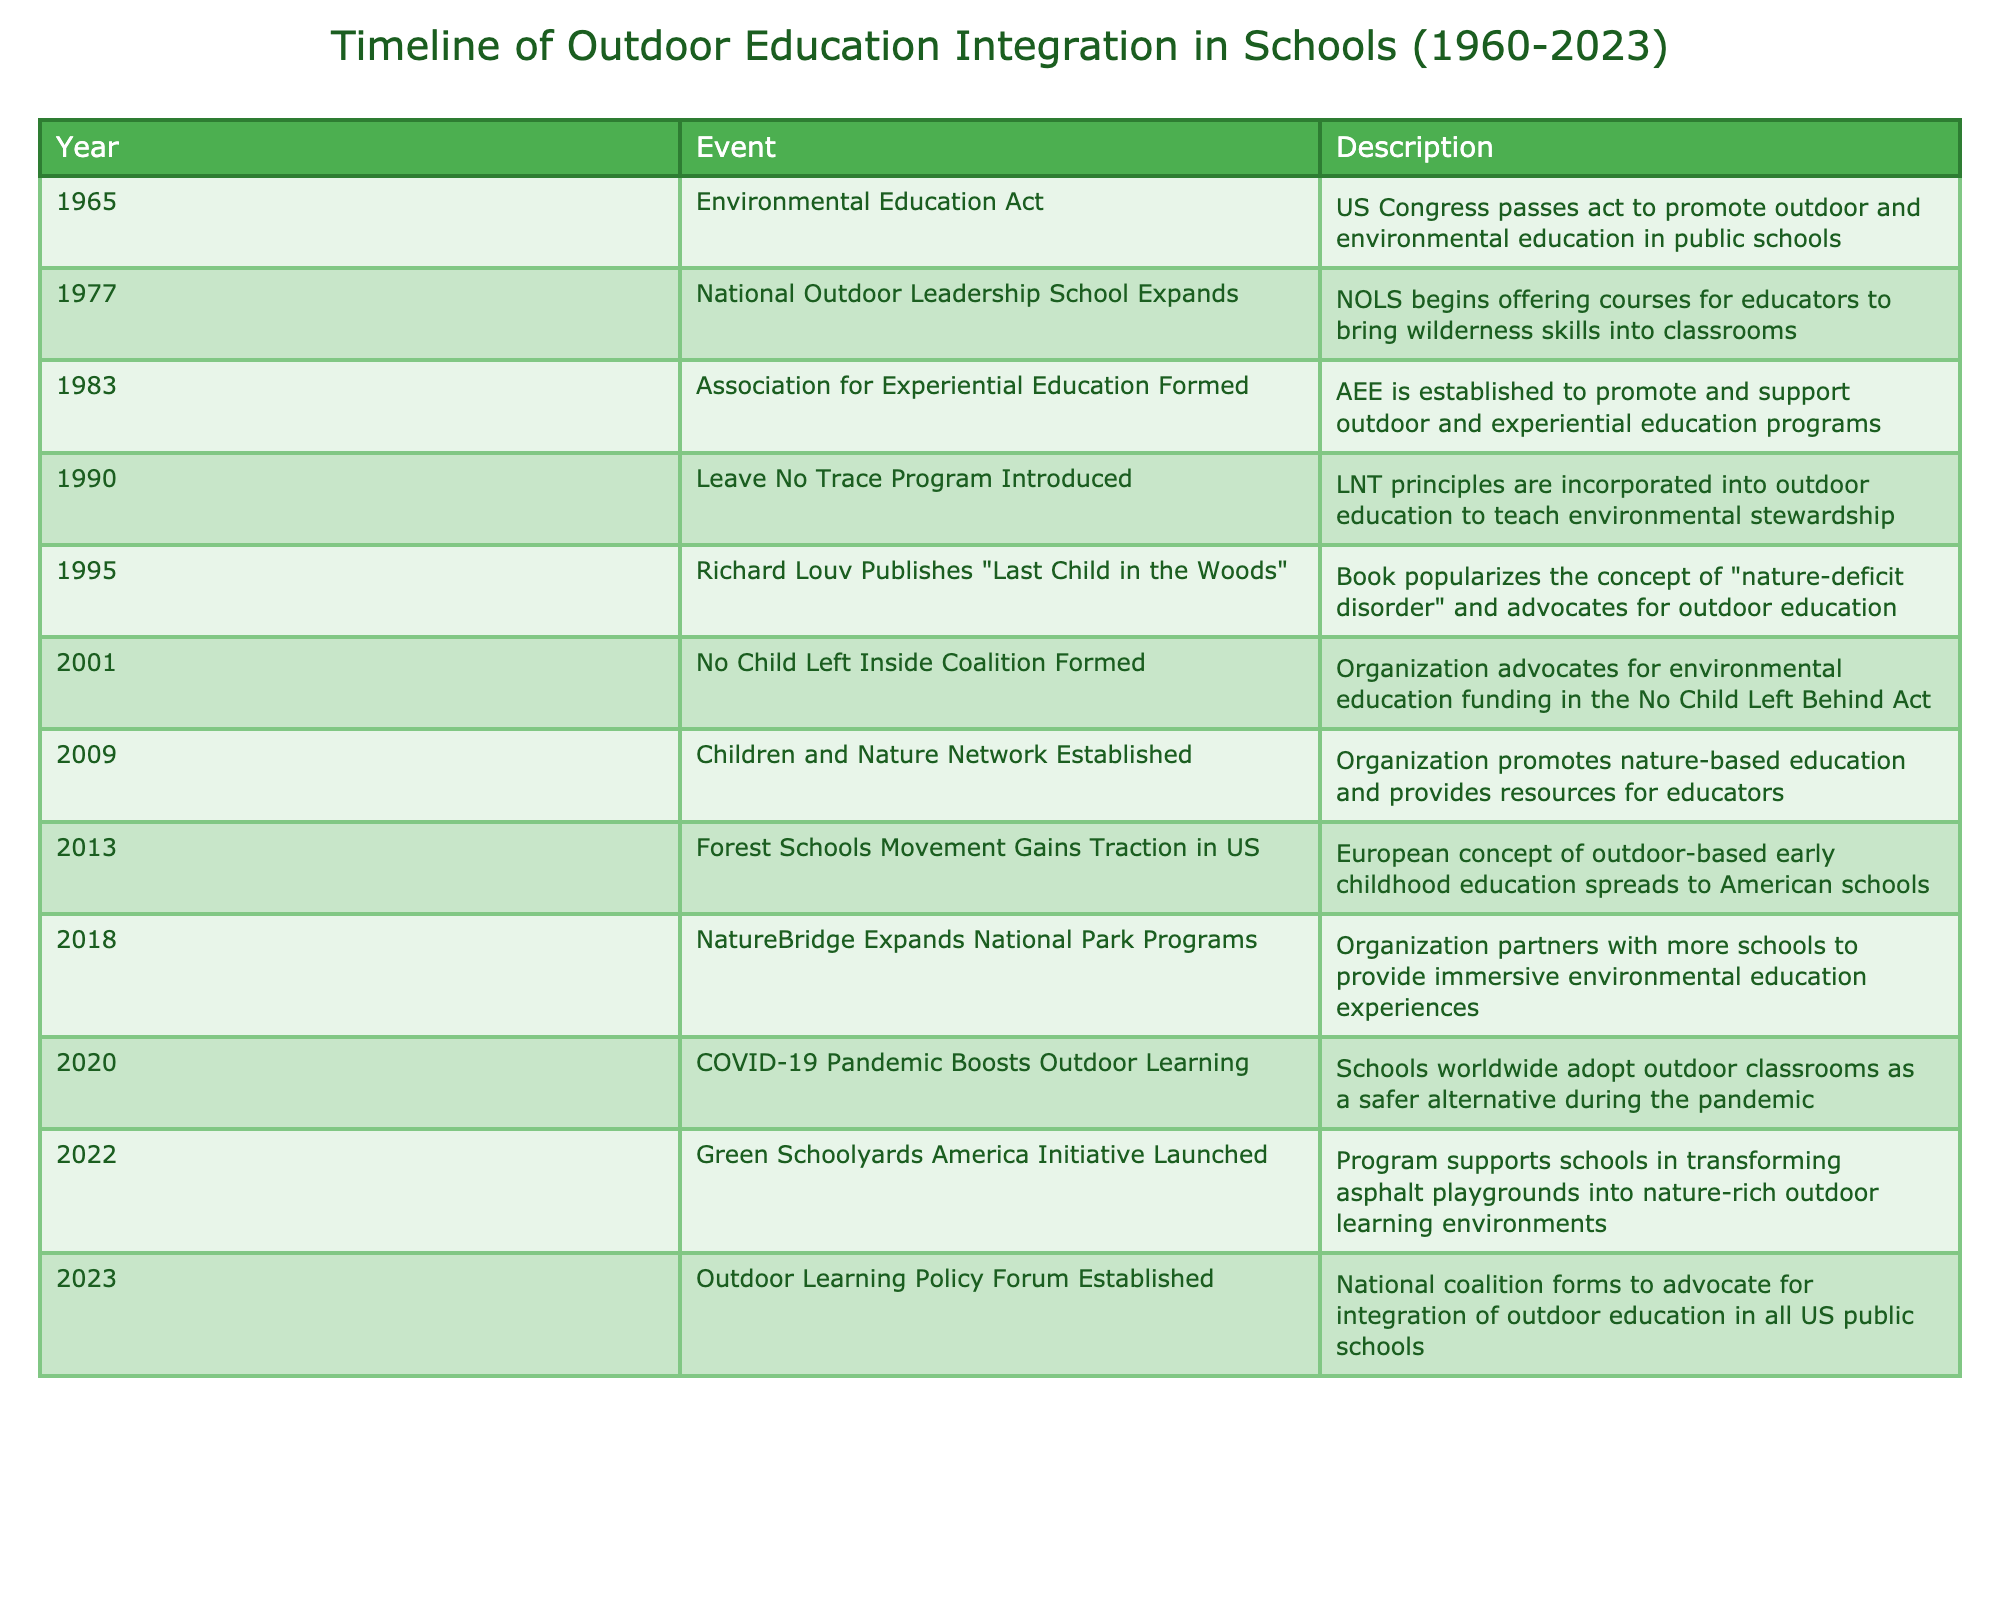What year did the Environmental Education Act pass? The table indicates that the Environmental Education Act was passed in 1965.
Answer: 1965 What organization was established in 1983 to promote outdoor and experiential education? According to the table, the Association for Experiential Education (AEE) was established in 1983 for this purpose.
Answer: Association for Experiential Education (AEE) In what year was the Leave No Trace Program introduced? The table lists that the Leave No Trace Program was introduced in 1990.
Answer: 1990 How many years elapsed between the publication of "Last Child in the Woods" and the formation of the No Child Left Inside Coalition? The book was published in 1995, and the No Child Left Inside Coalition was formed in 2001. The difference in years is 2001 - 1995 = 6.
Answer: 6 Was the Children and Nature Network established before the year 2010? Based on the table, the Children and Nature Network was established in 2009, which means it was indeed formed before 2010.
Answer: Yes What event marked a significant boost for outdoor learning in 2020? The table indicates that the COVID-19 pandemic caused schools worldwide to adopt outdoor classrooms as a safer alternative in 2020.
Answer: COVID-19 Pandemic What is the total number of events listed in the table that occurred after 2010? The events after 2010 are Forest Schools Movement (2013), NatureBridge Expansion (2018), COVID-19 (2020), Green Schoolyards Initiative (2022), and Outdoor Learning Policy Forum (2023). This totals to 5 events.
Answer: 5 What year saw the establishment of the Green Schoolyards America Initiative? The table indicates that the Green Schoolyards America Initiative was launched in 2022.
Answer: 2022 What percentage of the events listed occurred in the 2000s? There are 11 events in total, with 5 happening in the 2000s (2001, 2009). To find the percentage, divide 5 by 11 and multiply by 100, which gives approximately 45.45%.
Answer: 45.45% 